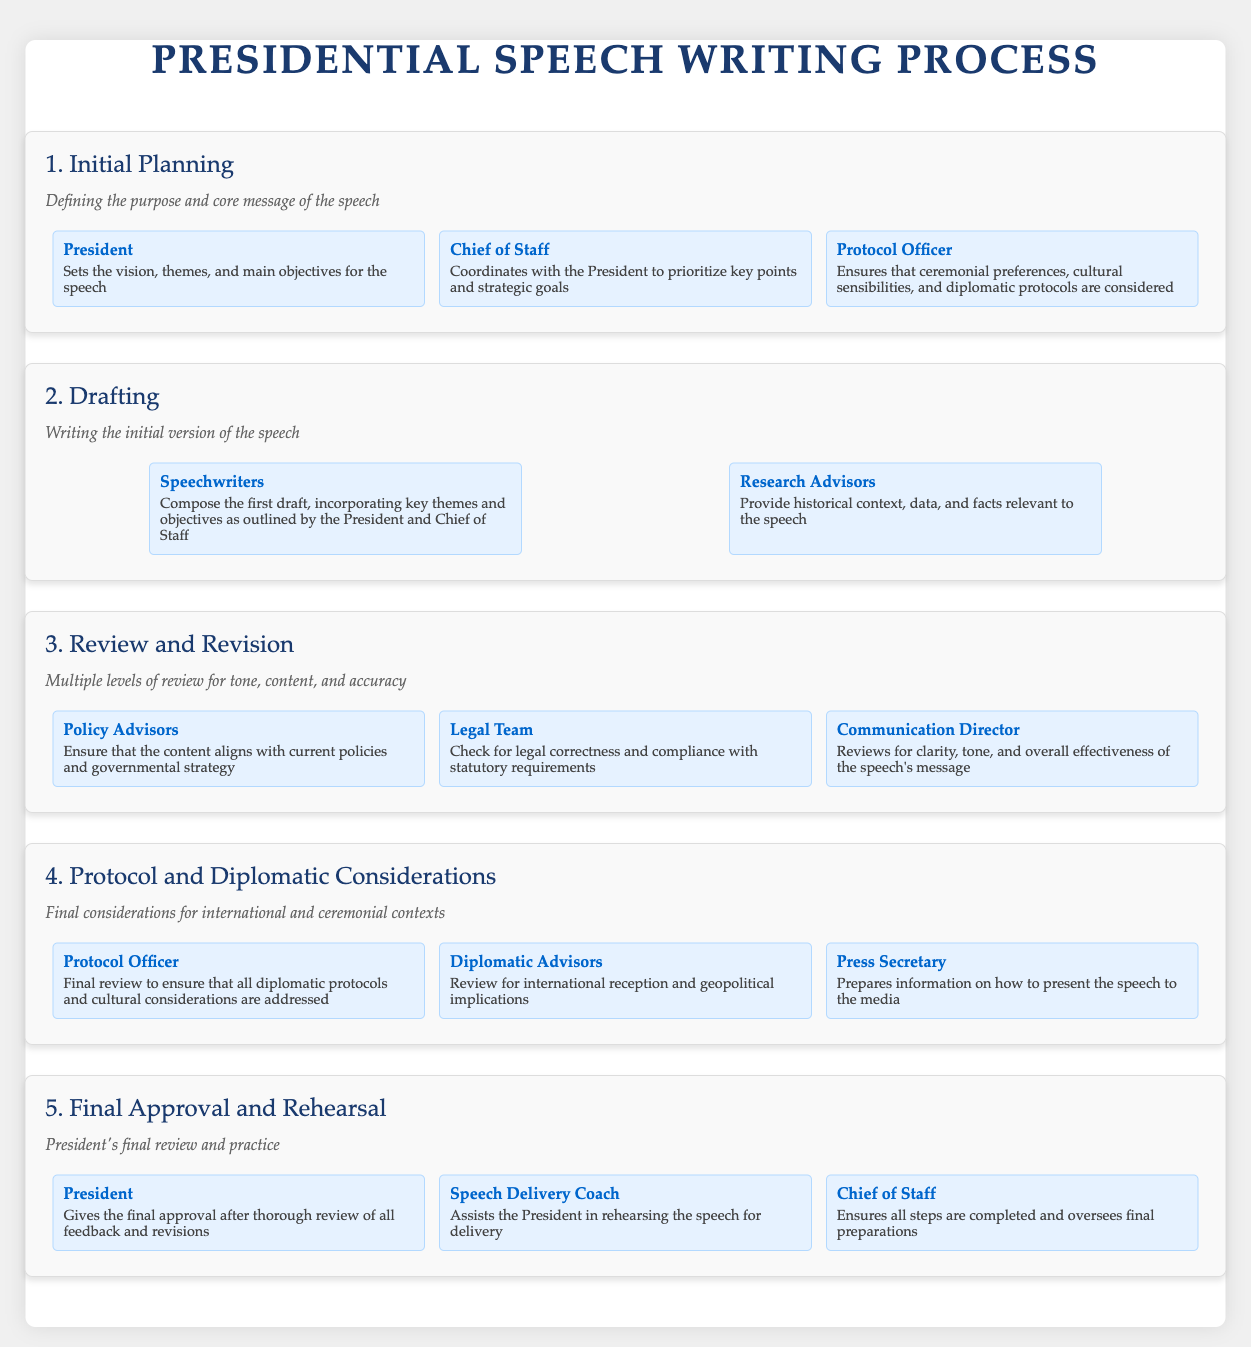What is the first step in the presidential speech writing process? The first step outlined in the document is "Initial Planning."
Answer: Initial Planning Who coordinates with the President during the initial planning phase? The Chief of Staff coordinates with the President to prioritize key points and strategic goals.
Answer: Chief of Staff What role does the Protocol Officer play in the drafting phase? The Protocol Officer ensures that ceremonial preferences, cultural sensibilities, and diplomatic protocols are considered.
Answer: Ensures protocols Which team checks for legal correctness during the review phase? The Legal Team is responsible for checking for legal correctness and compliance.
Answer: Legal Team How many entities are involved in the final approval and rehearsal step? There are three entities listed that are involved in the final approval and rehearsal.
Answer: Three What does the Speech Delivery Coach assist with? The Speech Delivery Coach assists the President in rehearsing the speech for delivery.
Answer: Rehearsing the speech What is the focus of the "Protocol and Diplomatic Considerations" step? This step focuses on final considerations for international and ceremonial contexts.
Answer: International and ceremonial contexts Which advisor provides historical context and data during the drafting phase? Research Advisors provide historical context, data, and facts relevant to the speech.
Answer: Research Advisors What is the main role of the Communication Director during the review phase? The Communication Director reviews for clarity, tone, and overall effectiveness of the speech's message.
Answer: Reviews for clarity Who gives the final approval of the speech? The President gives the final approval after thorough review of all feedback and revisions.
Answer: President 